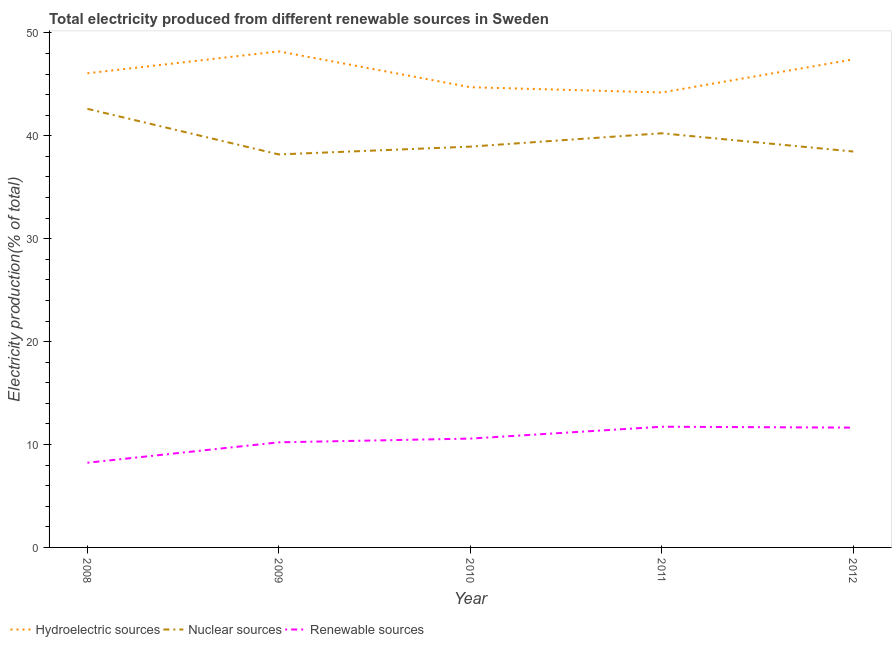Does the line corresponding to percentage of electricity produced by hydroelectric sources intersect with the line corresponding to percentage of electricity produced by renewable sources?
Your answer should be very brief. No. Is the number of lines equal to the number of legend labels?
Keep it short and to the point. Yes. What is the percentage of electricity produced by hydroelectric sources in 2010?
Your answer should be compact. 44.72. Across all years, what is the maximum percentage of electricity produced by hydroelectric sources?
Ensure brevity in your answer.  48.21. Across all years, what is the minimum percentage of electricity produced by hydroelectric sources?
Ensure brevity in your answer.  44.21. In which year was the percentage of electricity produced by hydroelectric sources maximum?
Make the answer very short. 2009. In which year was the percentage of electricity produced by hydroelectric sources minimum?
Offer a very short reply. 2011. What is the total percentage of electricity produced by nuclear sources in the graph?
Offer a terse response. 198.49. What is the difference between the percentage of electricity produced by renewable sources in 2009 and that in 2012?
Give a very brief answer. -1.43. What is the difference between the percentage of electricity produced by renewable sources in 2010 and the percentage of electricity produced by hydroelectric sources in 2008?
Provide a succinct answer. -35.5. What is the average percentage of electricity produced by renewable sources per year?
Give a very brief answer. 10.48. In the year 2009, what is the difference between the percentage of electricity produced by renewable sources and percentage of electricity produced by nuclear sources?
Offer a terse response. -27.98. What is the ratio of the percentage of electricity produced by renewable sources in 2008 to that in 2011?
Provide a succinct answer. 0.7. Is the percentage of electricity produced by hydroelectric sources in 2011 less than that in 2012?
Give a very brief answer. Yes. What is the difference between the highest and the second highest percentage of electricity produced by nuclear sources?
Your response must be concise. 2.37. What is the difference between the highest and the lowest percentage of electricity produced by nuclear sources?
Your response must be concise. 4.43. In how many years, is the percentage of electricity produced by hydroelectric sources greater than the average percentage of electricity produced by hydroelectric sources taken over all years?
Make the answer very short. 2. Is the sum of the percentage of electricity produced by nuclear sources in 2009 and 2010 greater than the maximum percentage of electricity produced by renewable sources across all years?
Offer a terse response. Yes. Is the percentage of electricity produced by hydroelectric sources strictly less than the percentage of electricity produced by nuclear sources over the years?
Give a very brief answer. No. Are the values on the major ticks of Y-axis written in scientific E-notation?
Make the answer very short. No. Does the graph contain grids?
Ensure brevity in your answer.  No. How many legend labels are there?
Your answer should be compact. 3. What is the title of the graph?
Provide a short and direct response. Total electricity produced from different renewable sources in Sweden. What is the label or title of the X-axis?
Keep it short and to the point. Year. What is the Electricity production(% of total) in Hydroelectric sources in 2008?
Give a very brief answer. 46.08. What is the Electricity production(% of total) of Nuclear sources in 2008?
Make the answer very short. 42.62. What is the Electricity production(% of total) of Renewable sources in 2008?
Offer a very short reply. 8.23. What is the Electricity production(% of total) of Hydroelectric sources in 2009?
Your answer should be compact. 48.21. What is the Electricity production(% of total) in Nuclear sources in 2009?
Give a very brief answer. 38.19. What is the Electricity production(% of total) in Renewable sources in 2009?
Your answer should be compact. 10.21. What is the Electricity production(% of total) of Hydroelectric sources in 2010?
Provide a short and direct response. 44.72. What is the Electricity production(% of total) of Nuclear sources in 2010?
Ensure brevity in your answer.  38.95. What is the Electricity production(% of total) in Renewable sources in 2010?
Keep it short and to the point. 10.58. What is the Electricity production(% of total) of Hydroelectric sources in 2011?
Keep it short and to the point. 44.21. What is the Electricity production(% of total) in Nuclear sources in 2011?
Your answer should be compact. 40.25. What is the Electricity production(% of total) of Renewable sources in 2011?
Provide a short and direct response. 11.73. What is the Electricity production(% of total) of Hydroelectric sources in 2012?
Keep it short and to the point. 47.42. What is the Electricity production(% of total) in Nuclear sources in 2012?
Offer a terse response. 38.48. What is the Electricity production(% of total) in Renewable sources in 2012?
Provide a short and direct response. 11.64. Across all years, what is the maximum Electricity production(% of total) in Hydroelectric sources?
Your answer should be compact. 48.21. Across all years, what is the maximum Electricity production(% of total) of Nuclear sources?
Your answer should be very brief. 42.62. Across all years, what is the maximum Electricity production(% of total) of Renewable sources?
Ensure brevity in your answer.  11.73. Across all years, what is the minimum Electricity production(% of total) in Hydroelectric sources?
Provide a short and direct response. 44.21. Across all years, what is the minimum Electricity production(% of total) of Nuclear sources?
Offer a very short reply. 38.19. Across all years, what is the minimum Electricity production(% of total) in Renewable sources?
Provide a short and direct response. 8.23. What is the total Electricity production(% of total) of Hydroelectric sources in the graph?
Your answer should be very brief. 230.65. What is the total Electricity production(% of total) of Nuclear sources in the graph?
Give a very brief answer. 198.49. What is the total Electricity production(% of total) of Renewable sources in the graph?
Provide a short and direct response. 52.39. What is the difference between the Electricity production(% of total) in Hydroelectric sources in 2008 and that in 2009?
Your response must be concise. -2.13. What is the difference between the Electricity production(% of total) in Nuclear sources in 2008 and that in 2009?
Your answer should be compact. 4.43. What is the difference between the Electricity production(% of total) in Renewable sources in 2008 and that in 2009?
Provide a succinct answer. -1.98. What is the difference between the Electricity production(% of total) of Hydroelectric sources in 2008 and that in 2010?
Ensure brevity in your answer.  1.35. What is the difference between the Electricity production(% of total) of Nuclear sources in 2008 and that in 2010?
Give a very brief answer. 3.67. What is the difference between the Electricity production(% of total) in Renewable sources in 2008 and that in 2010?
Ensure brevity in your answer.  -2.35. What is the difference between the Electricity production(% of total) in Hydroelectric sources in 2008 and that in 2011?
Your answer should be compact. 1.86. What is the difference between the Electricity production(% of total) of Nuclear sources in 2008 and that in 2011?
Your answer should be very brief. 2.37. What is the difference between the Electricity production(% of total) of Renewable sources in 2008 and that in 2011?
Offer a terse response. -3.5. What is the difference between the Electricity production(% of total) in Hydroelectric sources in 2008 and that in 2012?
Provide a succinct answer. -1.35. What is the difference between the Electricity production(% of total) in Nuclear sources in 2008 and that in 2012?
Your answer should be compact. 4.15. What is the difference between the Electricity production(% of total) in Renewable sources in 2008 and that in 2012?
Provide a succinct answer. -3.41. What is the difference between the Electricity production(% of total) of Hydroelectric sources in 2009 and that in 2010?
Provide a short and direct response. 3.48. What is the difference between the Electricity production(% of total) in Nuclear sources in 2009 and that in 2010?
Your response must be concise. -0.76. What is the difference between the Electricity production(% of total) in Renewable sources in 2009 and that in 2010?
Your response must be concise. -0.36. What is the difference between the Electricity production(% of total) of Hydroelectric sources in 2009 and that in 2011?
Give a very brief answer. 3.99. What is the difference between the Electricity production(% of total) in Nuclear sources in 2009 and that in 2011?
Give a very brief answer. -2.06. What is the difference between the Electricity production(% of total) of Renewable sources in 2009 and that in 2011?
Ensure brevity in your answer.  -1.52. What is the difference between the Electricity production(% of total) in Hydroelectric sources in 2009 and that in 2012?
Your answer should be compact. 0.78. What is the difference between the Electricity production(% of total) in Nuclear sources in 2009 and that in 2012?
Keep it short and to the point. -0.28. What is the difference between the Electricity production(% of total) of Renewable sources in 2009 and that in 2012?
Your answer should be very brief. -1.43. What is the difference between the Electricity production(% of total) in Hydroelectric sources in 2010 and that in 2011?
Provide a short and direct response. 0.51. What is the difference between the Electricity production(% of total) in Nuclear sources in 2010 and that in 2011?
Your answer should be very brief. -1.3. What is the difference between the Electricity production(% of total) in Renewable sources in 2010 and that in 2011?
Provide a succinct answer. -1.15. What is the difference between the Electricity production(% of total) of Hydroelectric sources in 2010 and that in 2012?
Your response must be concise. -2.7. What is the difference between the Electricity production(% of total) in Nuclear sources in 2010 and that in 2012?
Keep it short and to the point. 0.48. What is the difference between the Electricity production(% of total) of Renewable sources in 2010 and that in 2012?
Offer a terse response. -1.07. What is the difference between the Electricity production(% of total) in Hydroelectric sources in 2011 and that in 2012?
Offer a terse response. -3.21. What is the difference between the Electricity production(% of total) of Nuclear sources in 2011 and that in 2012?
Your answer should be very brief. 1.77. What is the difference between the Electricity production(% of total) of Renewable sources in 2011 and that in 2012?
Ensure brevity in your answer.  0.09. What is the difference between the Electricity production(% of total) in Hydroelectric sources in 2008 and the Electricity production(% of total) in Nuclear sources in 2009?
Keep it short and to the point. 7.89. What is the difference between the Electricity production(% of total) of Hydroelectric sources in 2008 and the Electricity production(% of total) of Renewable sources in 2009?
Your answer should be very brief. 35.87. What is the difference between the Electricity production(% of total) in Nuclear sources in 2008 and the Electricity production(% of total) in Renewable sources in 2009?
Your answer should be compact. 32.41. What is the difference between the Electricity production(% of total) in Hydroelectric sources in 2008 and the Electricity production(% of total) in Nuclear sources in 2010?
Provide a short and direct response. 7.13. What is the difference between the Electricity production(% of total) of Hydroelectric sources in 2008 and the Electricity production(% of total) of Renewable sources in 2010?
Ensure brevity in your answer.  35.5. What is the difference between the Electricity production(% of total) of Nuclear sources in 2008 and the Electricity production(% of total) of Renewable sources in 2010?
Ensure brevity in your answer.  32.05. What is the difference between the Electricity production(% of total) in Hydroelectric sources in 2008 and the Electricity production(% of total) in Nuclear sources in 2011?
Your answer should be compact. 5.83. What is the difference between the Electricity production(% of total) in Hydroelectric sources in 2008 and the Electricity production(% of total) in Renewable sources in 2011?
Give a very brief answer. 34.35. What is the difference between the Electricity production(% of total) in Nuclear sources in 2008 and the Electricity production(% of total) in Renewable sources in 2011?
Provide a succinct answer. 30.89. What is the difference between the Electricity production(% of total) in Hydroelectric sources in 2008 and the Electricity production(% of total) in Nuclear sources in 2012?
Your response must be concise. 7.6. What is the difference between the Electricity production(% of total) in Hydroelectric sources in 2008 and the Electricity production(% of total) in Renewable sources in 2012?
Provide a short and direct response. 34.44. What is the difference between the Electricity production(% of total) in Nuclear sources in 2008 and the Electricity production(% of total) in Renewable sources in 2012?
Your response must be concise. 30.98. What is the difference between the Electricity production(% of total) in Hydroelectric sources in 2009 and the Electricity production(% of total) in Nuclear sources in 2010?
Your answer should be compact. 9.25. What is the difference between the Electricity production(% of total) of Hydroelectric sources in 2009 and the Electricity production(% of total) of Renewable sources in 2010?
Provide a short and direct response. 37.63. What is the difference between the Electricity production(% of total) in Nuclear sources in 2009 and the Electricity production(% of total) in Renewable sources in 2010?
Your answer should be very brief. 27.62. What is the difference between the Electricity production(% of total) in Hydroelectric sources in 2009 and the Electricity production(% of total) in Nuclear sources in 2011?
Your answer should be compact. 7.96. What is the difference between the Electricity production(% of total) of Hydroelectric sources in 2009 and the Electricity production(% of total) of Renewable sources in 2011?
Provide a short and direct response. 36.48. What is the difference between the Electricity production(% of total) of Nuclear sources in 2009 and the Electricity production(% of total) of Renewable sources in 2011?
Provide a succinct answer. 26.46. What is the difference between the Electricity production(% of total) of Hydroelectric sources in 2009 and the Electricity production(% of total) of Nuclear sources in 2012?
Your answer should be very brief. 9.73. What is the difference between the Electricity production(% of total) in Hydroelectric sources in 2009 and the Electricity production(% of total) in Renewable sources in 2012?
Provide a short and direct response. 36.56. What is the difference between the Electricity production(% of total) of Nuclear sources in 2009 and the Electricity production(% of total) of Renewable sources in 2012?
Offer a very short reply. 26.55. What is the difference between the Electricity production(% of total) in Hydroelectric sources in 2010 and the Electricity production(% of total) in Nuclear sources in 2011?
Your answer should be very brief. 4.48. What is the difference between the Electricity production(% of total) in Hydroelectric sources in 2010 and the Electricity production(% of total) in Renewable sources in 2011?
Provide a succinct answer. 32.99. What is the difference between the Electricity production(% of total) in Nuclear sources in 2010 and the Electricity production(% of total) in Renewable sources in 2011?
Keep it short and to the point. 27.22. What is the difference between the Electricity production(% of total) in Hydroelectric sources in 2010 and the Electricity production(% of total) in Nuclear sources in 2012?
Offer a very short reply. 6.25. What is the difference between the Electricity production(% of total) of Hydroelectric sources in 2010 and the Electricity production(% of total) of Renewable sources in 2012?
Provide a succinct answer. 33.08. What is the difference between the Electricity production(% of total) of Nuclear sources in 2010 and the Electricity production(% of total) of Renewable sources in 2012?
Provide a succinct answer. 27.31. What is the difference between the Electricity production(% of total) in Hydroelectric sources in 2011 and the Electricity production(% of total) in Nuclear sources in 2012?
Give a very brief answer. 5.74. What is the difference between the Electricity production(% of total) in Hydroelectric sources in 2011 and the Electricity production(% of total) in Renewable sources in 2012?
Your response must be concise. 32.57. What is the difference between the Electricity production(% of total) of Nuclear sources in 2011 and the Electricity production(% of total) of Renewable sources in 2012?
Offer a terse response. 28.61. What is the average Electricity production(% of total) in Hydroelectric sources per year?
Make the answer very short. 46.13. What is the average Electricity production(% of total) of Nuclear sources per year?
Your answer should be compact. 39.7. What is the average Electricity production(% of total) in Renewable sources per year?
Offer a terse response. 10.48. In the year 2008, what is the difference between the Electricity production(% of total) of Hydroelectric sources and Electricity production(% of total) of Nuclear sources?
Offer a terse response. 3.46. In the year 2008, what is the difference between the Electricity production(% of total) in Hydroelectric sources and Electricity production(% of total) in Renewable sources?
Your answer should be compact. 37.85. In the year 2008, what is the difference between the Electricity production(% of total) in Nuclear sources and Electricity production(% of total) in Renewable sources?
Your answer should be very brief. 34.39. In the year 2009, what is the difference between the Electricity production(% of total) of Hydroelectric sources and Electricity production(% of total) of Nuclear sources?
Provide a short and direct response. 10.01. In the year 2009, what is the difference between the Electricity production(% of total) of Hydroelectric sources and Electricity production(% of total) of Renewable sources?
Make the answer very short. 37.99. In the year 2009, what is the difference between the Electricity production(% of total) of Nuclear sources and Electricity production(% of total) of Renewable sources?
Ensure brevity in your answer.  27.98. In the year 2010, what is the difference between the Electricity production(% of total) in Hydroelectric sources and Electricity production(% of total) in Nuclear sources?
Provide a succinct answer. 5.77. In the year 2010, what is the difference between the Electricity production(% of total) of Hydroelectric sources and Electricity production(% of total) of Renewable sources?
Provide a short and direct response. 34.15. In the year 2010, what is the difference between the Electricity production(% of total) of Nuclear sources and Electricity production(% of total) of Renewable sources?
Provide a succinct answer. 28.37. In the year 2011, what is the difference between the Electricity production(% of total) of Hydroelectric sources and Electricity production(% of total) of Nuclear sources?
Provide a short and direct response. 3.97. In the year 2011, what is the difference between the Electricity production(% of total) in Hydroelectric sources and Electricity production(% of total) in Renewable sources?
Provide a succinct answer. 32.48. In the year 2011, what is the difference between the Electricity production(% of total) of Nuclear sources and Electricity production(% of total) of Renewable sources?
Offer a terse response. 28.52. In the year 2012, what is the difference between the Electricity production(% of total) in Hydroelectric sources and Electricity production(% of total) in Nuclear sources?
Your answer should be compact. 8.95. In the year 2012, what is the difference between the Electricity production(% of total) of Hydroelectric sources and Electricity production(% of total) of Renewable sources?
Your answer should be compact. 35.78. In the year 2012, what is the difference between the Electricity production(% of total) in Nuclear sources and Electricity production(% of total) in Renewable sources?
Your response must be concise. 26.83. What is the ratio of the Electricity production(% of total) in Hydroelectric sources in 2008 to that in 2009?
Your response must be concise. 0.96. What is the ratio of the Electricity production(% of total) in Nuclear sources in 2008 to that in 2009?
Offer a very short reply. 1.12. What is the ratio of the Electricity production(% of total) of Renewable sources in 2008 to that in 2009?
Provide a succinct answer. 0.81. What is the ratio of the Electricity production(% of total) of Hydroelectric sources in 2008 to that in 2010?
Keep it short and to the point. 1.03. What is the ratio of the Electricity production(% of total) of Nuclear sources in 2008 to that in 2010?
Provide a short and direct response. 1.09. What is the ratio of the Electricity production(% of total) in Renewable sources in 2008 to that in 2010?
Make the answer very short. 0.78. What is the ratio of the Electricity production(% of total) of Hydroelectric sources in 2008 to that in 2011?
Make the answer very short. 1.04. What is the ratio of the Electricity production(% of total) of Nuclear sources in 2008 to that in 2011?
Your response must be concise. 1.06. What is the ratio of the Electricity production(% of total) in Renewable sources in 2008 to that in 2011?
Keep it short and to the point. 0.7. What is the ratio of the Electricity production(% of total) of Hydroelectric sources in 2008 to that in 2012?
Your answer should be very brief. 0.97. What is the ratio of the Electricity production(% of total) of Nuclear sources in 2008 to that in 2012?
Provide a short and direct response. 1.11. What is the ratio of the Electricity production(% of total) in Renewable sources in 2008 to that in 2012?
Your answer should be very brief. 0.71. What is the ratio of the Electricity production(% of total) in Hydroelectric sources in 2009 to that in 2010?
Offer a very short reply. 1.08. What is the ratio of the Electricity production(% of total) of Nuclear sources in 2009 to that in 2010?
Offer a very short reply. 0.98. What is the ratio of the Electricity production(% of total) of Renewable sources in 2009 to that in 2010?
Your response must be concise. 0.97. What is the ratio of the Electricity production(% of total) in Hydroelectric sources in 2009 to that in 2011?
Your response must be concise. 1.09. What is the ratio of the Electricity production(% of total) of Nuclear sources in 2009 to that in 2011?
Provide a short and direct response. 0.95. What is the ratio of the Electricity production(% of total) in Renewable sources in 2009 to that in 2011?
Offer a very short reply. 0.87. What is the ratio of the Electricity production(% of total) of Hydroelectric sources in 2009 to that in 2012?
Provide a succinct answer. 1.02. What is the ratio of the Electricity production(% of total) in Renewable sources in 2009 to that in 2012?
Your response must be concise. 0.88. What is the ratio of the Electricity production(% of total) in Hydroelectric sources in 2010 to that in 2011?
Ensure brevity in your answer.  1.01. What is the ratio of the Electricity production(% of total) in Nuclear sources in 2010 to that in 2011?
Your answer should be very brief. 0.97. What is the ratio of the Electricity production(% of total) in Renewable sources in 2010 to that in 2011?
Provide a succinct answer. 0.9. What is the ratio of the Electricity production(% of total) in Hydroelectric sources in 2010 to that in 2012?
Offer a terse response. 0.94. What is the ratio of the Electricity production(% of total) of Nuclear sources in 2010 to that in 2012?
Your response must be concise. 1.01. What is the ratio of the Electricity production(% of total) of Renewable sources in 2010 to that in 2012?
Keep it short and to the point. 0.91. What is the ratio of the Electricity production(% of total) of Hydroelectric sources in 2011 to that in 2012?
Keep it short and to the point. 0.93. What is the ratio of the Electricity production(% of total) of Nuclear sources in 2011 to that in 2012?
Ensure brevity in your answer.  1.05. What is the ratio of the Electricity production(% of total) of Renewable sources in 2011 to that in 2012?
Your answer should be very brief. 1.01. What is the difference between the highest and the second highest Electricity production(% of total) of Hydroelectric sources?
Keep it short and to the point. 0.78. What is the difference between the highest and the second highest Electricity production(% of total) of Nuclear sources?
Offer a very short reply. 2.37. What is the difference between the highest and the second highest Electricity production(% of total) of Renewable sources?
Offer a terse response. 0.09. What is the difference between the highest and the lowest Electricity production(% of total) of Hydroelectric sources?
Your response must be concise. 3.99. What is the difference between the highest and the lowest Electricity production(% of total) of Nuclear sources?
Ensure brevity in your answer.  4.43. What is the difference between the highest and the lowest Electricity production(% of total) of Renewable sources?
Provide a succinct answer. 3.5. 